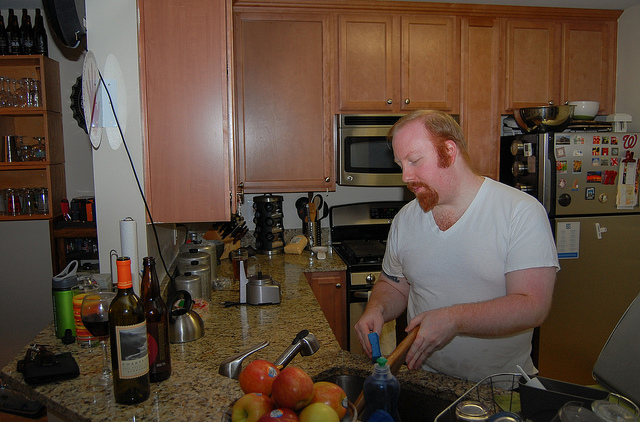How many stoves are there? 1 